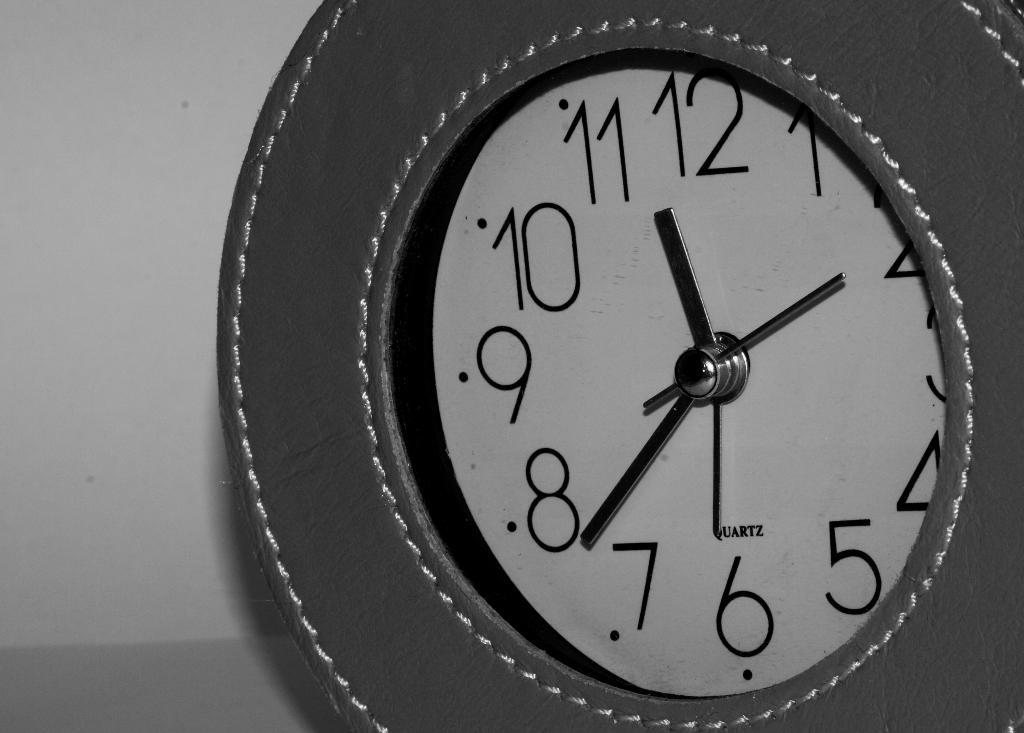<image>
Provide a brief description of the given image. A clock with a white face has the Quartz logo on it. 